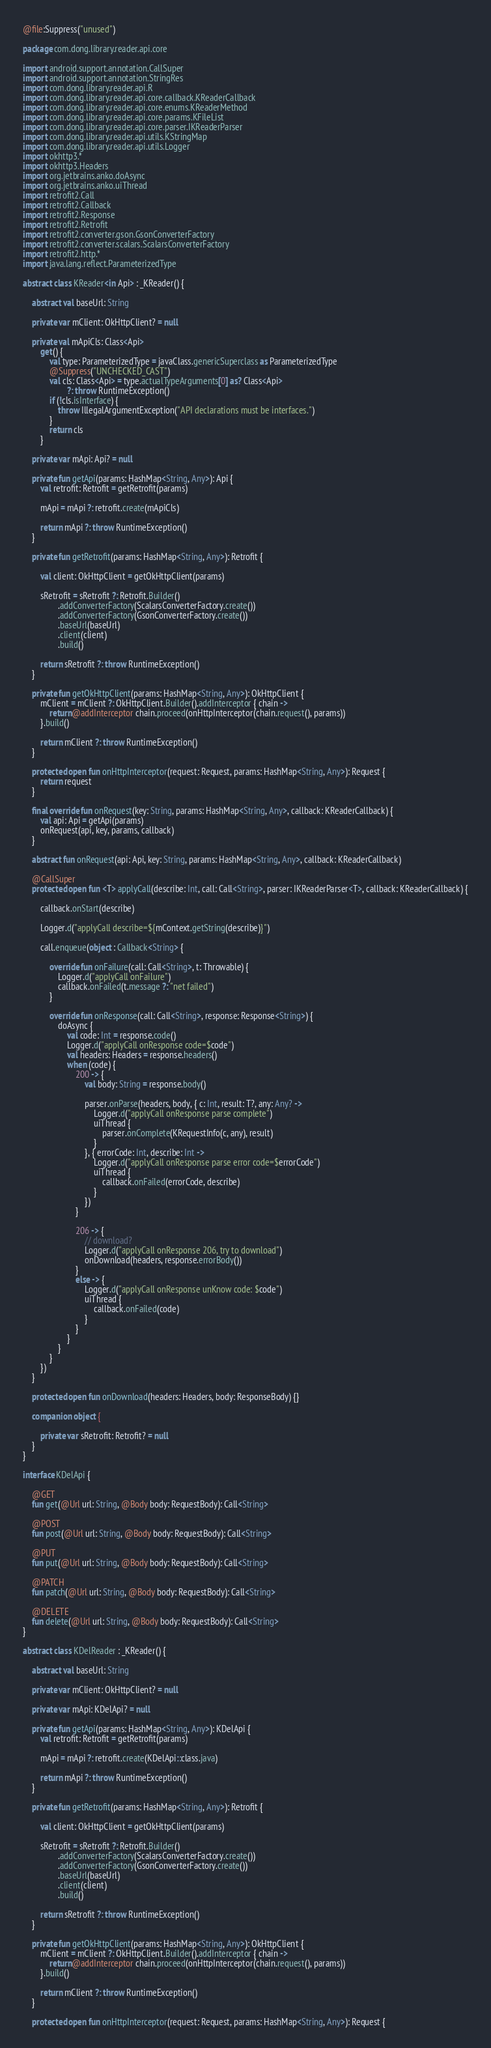Convert code to text. <code><loc_0><loc_0><loc_500><loc_500><_Kotlin_>@file:Suppress("unused")

package com.dong.library.reader.api.core

import android.support.annotation.CallSuper
import android.support.annotation.StringRes
import com.dong.library.reader.api.R
import com.dong.library.reader.api.core.callback.KReaderCallback
import com.dong.library.reader.api.core.enums.KReaderMethod
import com.dong.library.reader.api.core.params.KFileList
import com.dong.library.reader.api.core.parser.IKReaderParser
import com.dong.library.reader.api.utils.KStringMap
import com.dong.library.reader.api.utils.Logger
import okhttp3.*
import okhttp3.Headers
import org.jetbrains.anko.doAsync
import org.jetbrains.anko.uiThread
import retrofit2.Call
import retrofit2.Callback
import retrofit2.Response
import retrofit2.Retrofit
import retrofit2.converter.gson.GsonConverterFactory
import retrofit2.converter.scalars.ScalarsConverterFactory
import retrofit2.http.*
import java.lang.reflect.ParameterizedType

abstract class KReader<in Api> : _KReader() {

    abstract val baseUrl: String

    private var mClient: OkHttpClient? = null

    private val mApiCls: Class<Api>
        get() {
            val type: ParameterizedType = javaClass.genericSuperclass as ParameterizedType
            @Suppress("UNCHECKED_CAST")
            val cls: Class<Api> = type.actualTypeArguments[0] as? Class<Api>
                    ?: throw RuntimeException()
            if (!cls.isInterface) {
                throw IllegalArgumentException("API declarations must be interfaces.")
            }
            return cls
        }

    private var mApi: Api? = null

    private fun getApi(params: HashMap<String, Any>): Api {
        val retrofit: Retrofit = getRetrofit(params)

        mApi = mApi ?: retrofit.create(mApiCls)

        return mApi ?: throw RuntimeException()
    }

    private fun getRetrofit(params: HashMap<String, Any>): Retrofit {

        val client: OkHttpClient = getOkHttpClient(params)

        sRetrofit = sRetrofit ?: Retrofit.Builder()
                .addConverterFactory(ScalarsConverterFactory.create())
                .addConverterFactory(GsonConverterFactory.create())
                .baseUrl(baseUrl)
                .client(client)
                .build()

        return sRetrofit ?: throw RuntimeException()
    }

    private fun getOkHttpClient(params: HashMap<String, Any>): OkHttpClient {
        mClient = mClient ?: OkHttpClient.Builder().addInterceptor { chain ->
            return@addInterceptor chain.proceed(onHttpInterceptor(chain.request(), params))
        }.build()

        return mClient ?: throw RuntimeException()
    }

    protected open fun onHttpInterceptor(request: Request, params: HashMap<String, Any>): Request {
        return request
    }

    final override fun onRequest(key: String, params: HashMap<String, Any>, callback: KReaderCallback) {
        val api: Api = getApi(params)
        onRequest(api, key, params, callback)
    }

    abstract fun onRequest(api: Api, key: String, params: HashMap<String, Any>, callback: KReaderCallback)

    @CallSuper
    protected open fun <T> applyCall(describe: Int, call: Call<String>, parser: IKReaderParser<T>, callback: KReaderCallback) {

        callback.onStart(describe)

        Logger.d("applyCall describe=${mContext.getString(describe)}")

        call.enqueue(object : Callback<String> {

            override fun onFailure(call: Call<String>, t: Throwable) {
                Logger.d("applyCall onFailure")
                callback.onFailed(t.message ?: "net failed")
            }

            override fun onResponse(call: Call<String>, response: Response<String>) {
                doAsync {
                    val code: Int = response.code()
                    Logger.d("applyCall onResponse code=$code")
                    val headers: Headers = response.headers()
                    when (code) {
                        200 -> {
                            val body: String = response.body()

                            parser.onParse(headers, body, { c: Int, result: T?, any: Any? ->
                                Logger.d("applyCall onResponse parse complete")
                                uiThread {
                                    parser.onComplete(KRequestInfo(c, any), result)
                                }
                            }, { errorCode: Int, describe: Int ->
                                Logger.d("applyCall onResponse parse error code=$errorCode")
                                uiThread {
                                    callback.onFailed(errorCode, describe)
                                }
                            })
                        }

                        206 -> {
                            // download?
                            Logger.d("applyCall onResponse 206, try to download")
                            onDownload(headers, response.errorBody())
                        }
                        else -> {
                            Logger.d("applyCall onResponse unKnow code: $code")
                            uiThread {
                                callback.onFailed(code)
                            }
                        }
                    }
                }
            }
        })
    }

    protected open fun onDownload(headers: Headers, body: ResponseBody) {}

    companion object {

        private var sRetrofit: Retrofit? = null
    }
}

interface KDelApi {

    @GET
    fun get(@Url url: String, @Body body: RequestBody): Call<String>

    @POST
    fun post(@Url url: String, @Body body: RequestBody): Call<String>

    @PUT
    fun put(@Url url: String, @Body body: RequestBody): Call<String>

    @PATCH
    fun patch(@Url url: String, @Body body: RequestBody): Call<String>

    @DELETE
    fun delete(@Url url: String, @Body body: RequestBody): Call<String>
}

abstract class KDelReader : _KReader() {

    abstract val baseUrl: String

    private var mClient: OkHttpClient? = null

    private var mApi: KDelApi? = null

    private fun getApi(params: HashMap<String, Any>): KDelApi {
        val retrofit: Retrofit = getRetrofit(params)

        mApi = mApi ?: retrofit.create(KDelApi::class.java)

        return mApi ?: throw RuntimeException()
    }

    private fun getRetrofit(params: HashMap<String, Any>): Retrofit {

        val client: OkHttpClient = getOkHttpClient(params)

        sRetrofit = sRetrofit ?: Retrofit.Builder()
                .addConverterFactory(ScalarsConverterFactory.create())
                .addConverterFactory(GsonConverterFactory.create())
                .baseUrl(baseUrl)
                .client(client)
                .build()

        return sRetrofit ?: throw RuntimeException()
    }

    private fun getOkHttpClient(params: HashMap<String, Any>): OkHttpClient {
        mClient = mClient ?: OkHttpClient.Builder().addInterceptor { chain ->
            return@addInterceptor chain.proceed(onHttpInterceptor(chain.request(), params))
        }.build()

        return mClient ?: throw RuntimeException()
    }

    protected open fun onHttpInterceptor(request: Request, params: HashMap<String, Any>): Request {</code> 